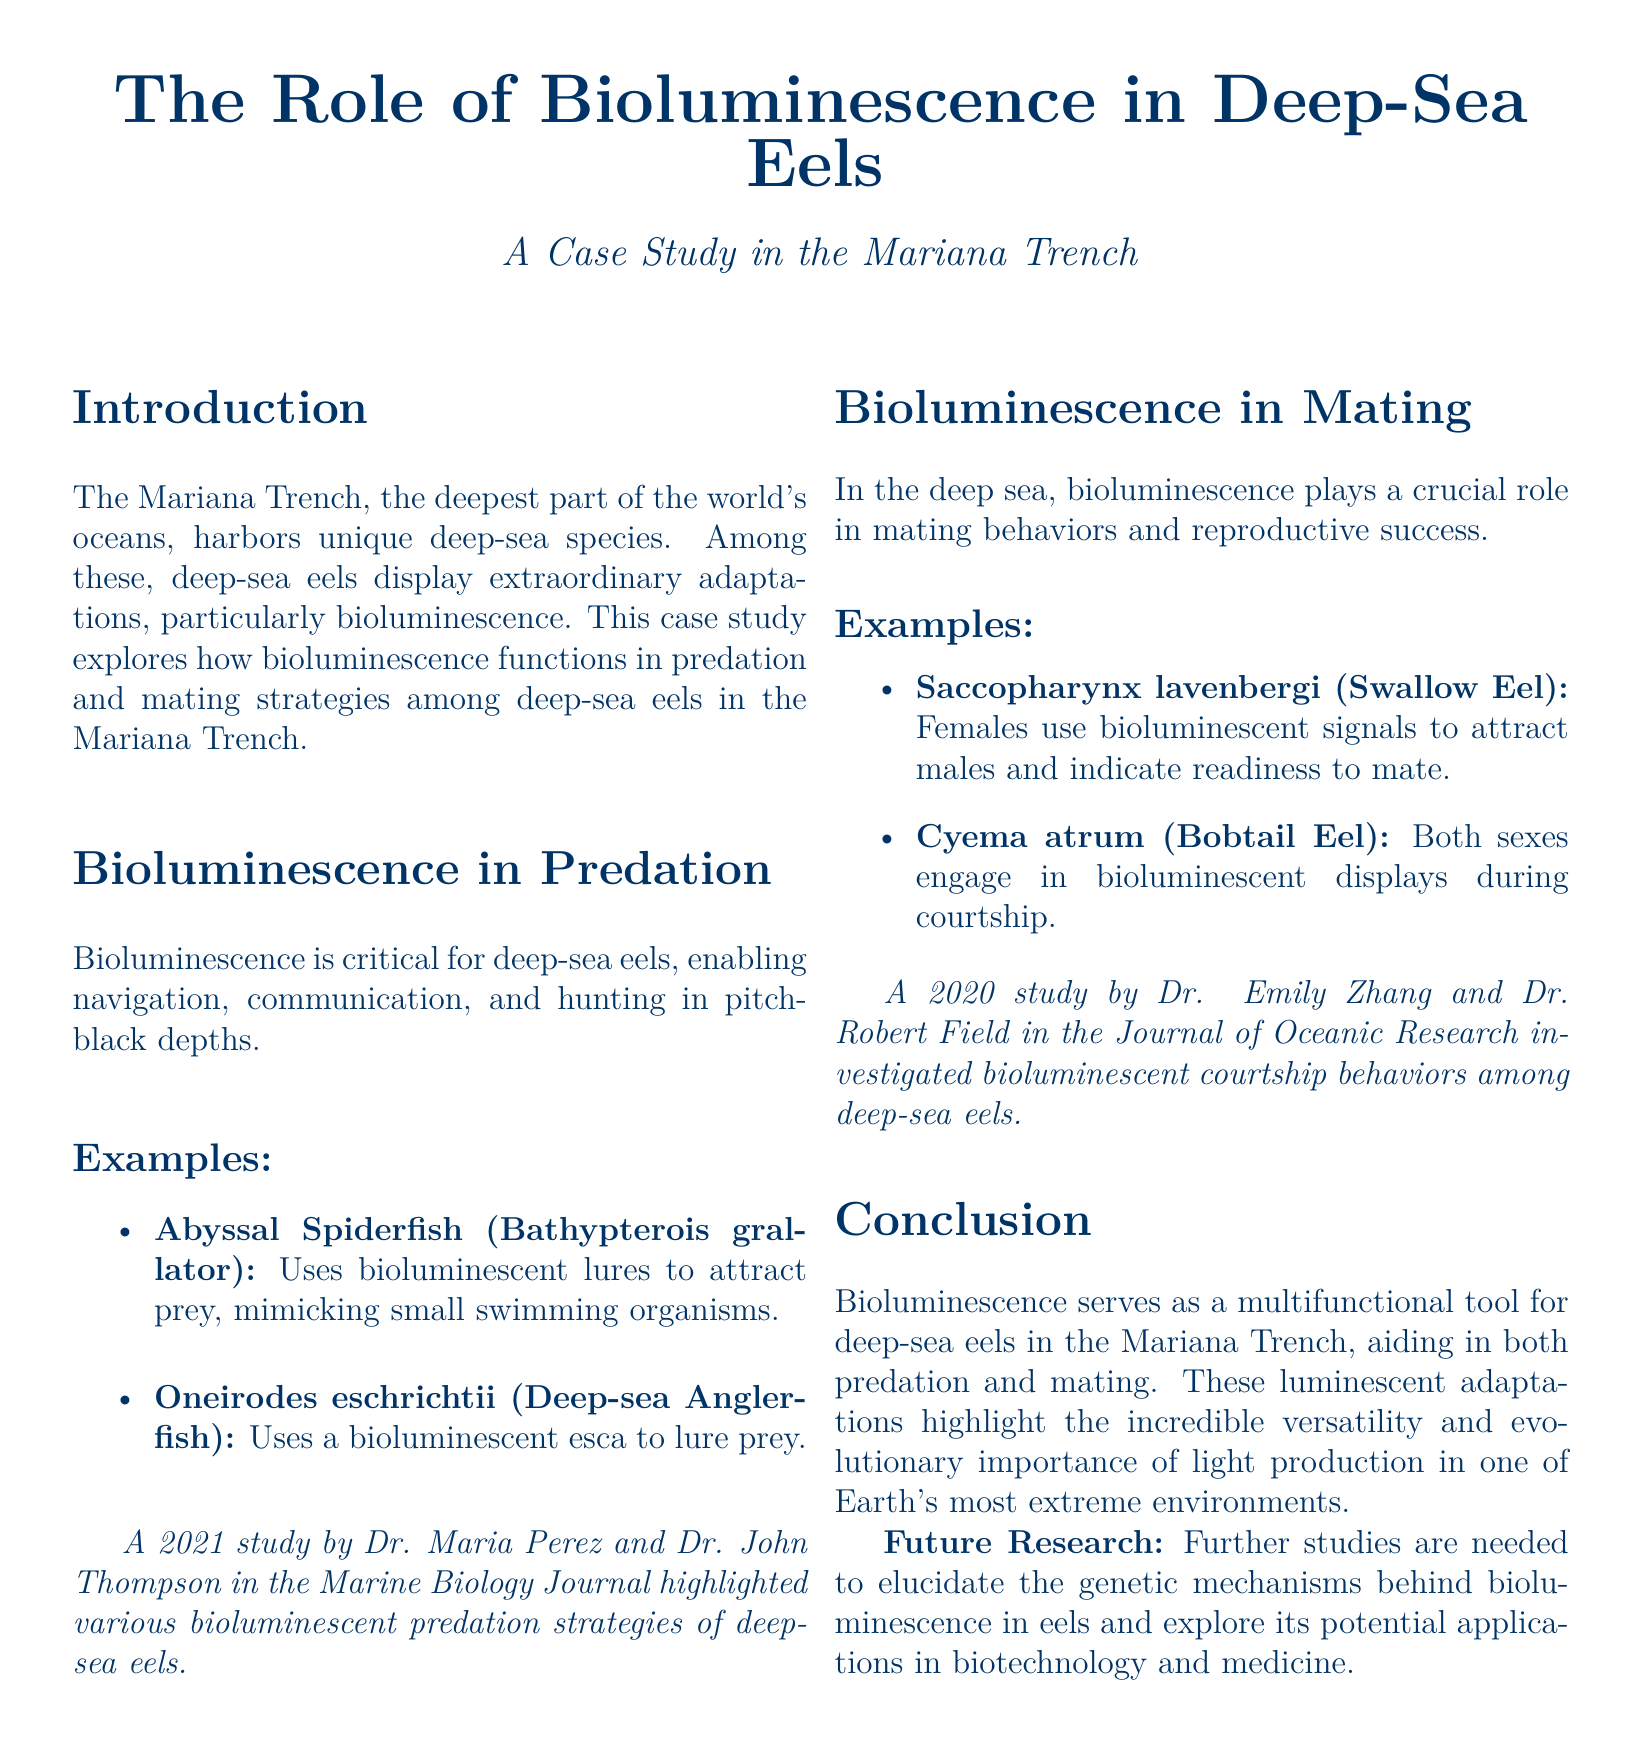what is the title of the case study? The title of the case study is clearly stated at the beginning of the document.
Answer: The Role of Bioluminescence in Deep-Sea Eels which species uses bioluminescent lures to attract prey? This information is found under the "Bioluminescence in Predation" section, listing specific examples.
Answer: Abyssal Spiderfish what role does bioluminescence play in mating behaviors? The document specifies the function of bioluminescence in mating under "Bioluminescence in Mating."
Answer: Attracting mates who conducted a study on bioluminescent courtship behaviors in 2020? This is mentioned in the "Bioluminescence in Mating" section, where studies are cited.
Answer: Dr. Emily Zhang and Dr. Robert Field how many species are mentioned as examples of bioluminescence in predation? The document lists two specific examples in the respective section.
Answer: Two what is a future research direction mentioned in the conclusion? The conclusion includes suggestions for further studies and elaborates on next steps.
Answer: Genetic mechanisms behind bioluminescence which species engages in bioluminescent displays during courtship? This detail is provided as an example in the "Bioluminescence in Mating" section.
Answer: Cyema atrum what journal published the 2021 study on bioluminescent predation strategies? This information is found in the reference included in the "Bioluminescence in Predation" section.
Answer: Marine Biology Journal 